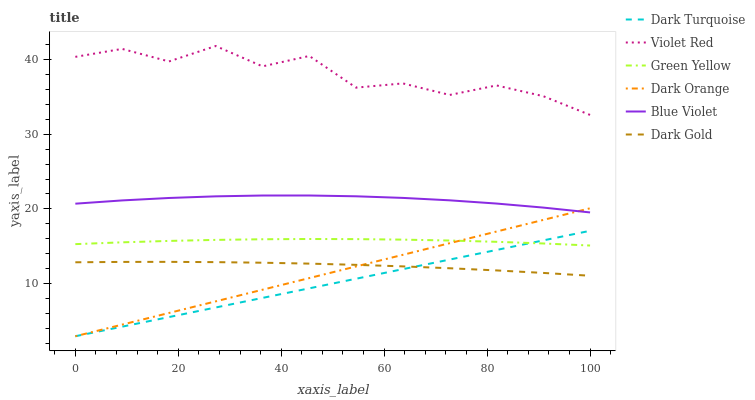Does Dark Gold have the minimum area under the curve?
Answer yes or no. No. Does Dark Gold have the maximum area under the curve?
Answer yes or no. No. Is Dark Gold the smoothest?
Answer yes or no. No. Is Dark Gold the roughest?
Answer yes or no. No. Does Dark Gold have the lowest value?
Answer yes or no. No. Does Dark Gold have the highest value?
Answer yes or no. No. Is Dark Orange less than Violet Red?
Answer yes or no. Yes. Is Blue Violet greater than Green Yellow?
Answer yes or no. Yes. Does Dark Orange intersect Violet Red?
Answer yes or no. No. 